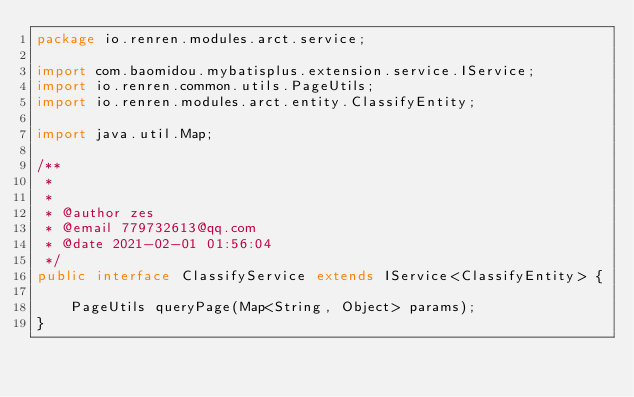<code> <loc_0><loc_0><loc_500><loc_500><_Java_>package io.renren.modules.arct.service;

import com.baomidou.mybatisplus.extension.service.IService;
import io.renren.common.utils.PageUtils;
import io.renren.modules.arct.entity.ClassifyEntity;

import java.util.Map;

/**
 * 
 *
 * @author zes
 * @email 779732613@qq.com
 * @date 2021-02-01 01:56:04
 */
public interface ClassifyService extends IService<ClassifyEntity> {

    PageUtils queryPage(Map<String, Object> params);
}

</code> 